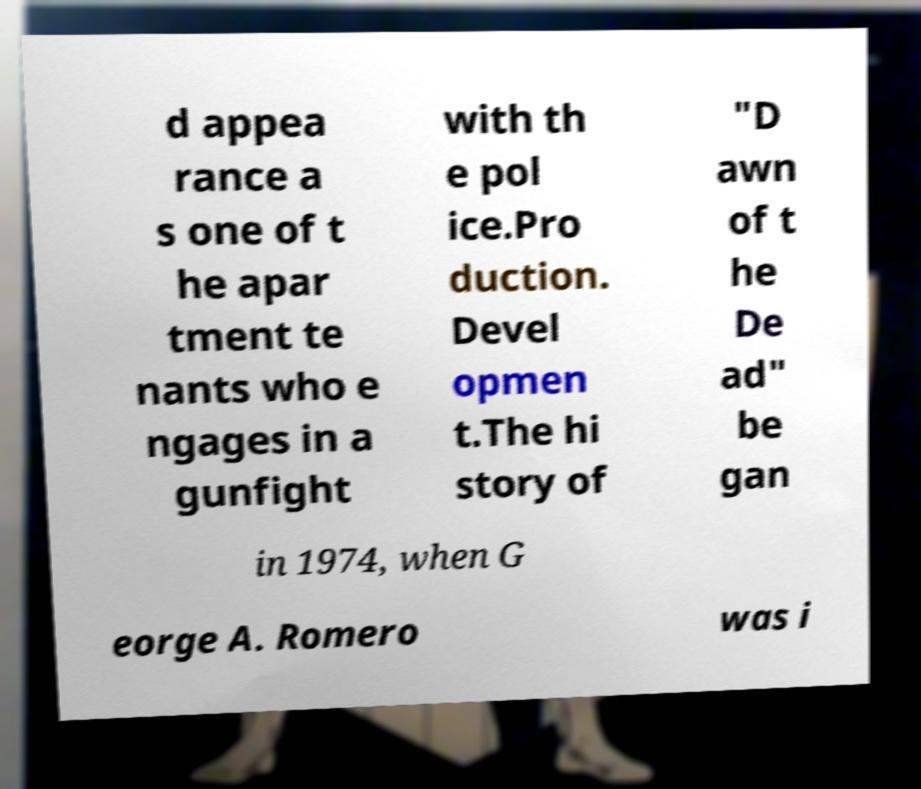Can you accurately transcribe the text from the provided image for me? d appea rance a s one of t he apar tment te nants who e ngages in a gunfight with th e pol ice.Pro duction. Devel opmen t.The hi story of "D awn of t he De ad" be gan in 1974, when G eorge A. Romero was i 